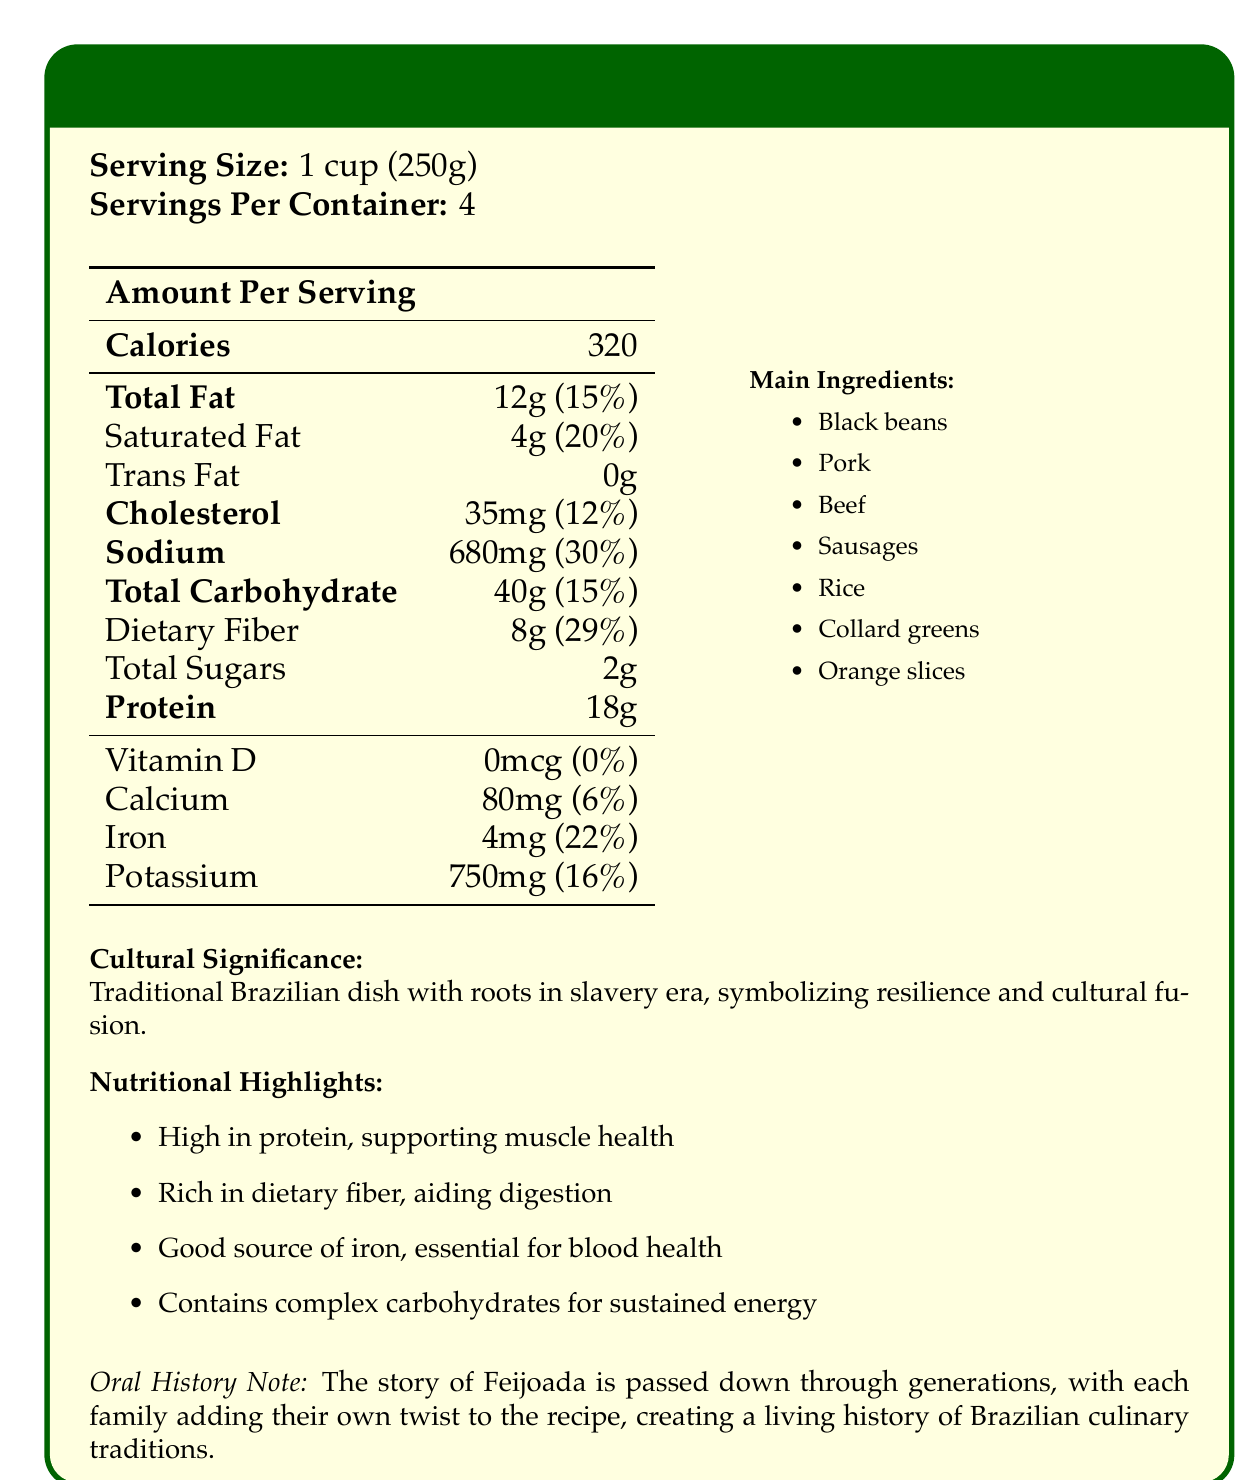what is the serving size of Feijoada? The serving size is clearly mentioned as "1 cup (250g)" in the minipage section of the document.
Answer: 1 cup (250g) how many calories are there per serving of Feijoada? The document states that there are 320 calories per serving under the "Calories" row in the table.
Answer: 320 what is the daily value percentage of dietary fiber in Feijoada? The daily value percentage for dietary fiber is listed as 29% next to the dietary fiber amount of 8g in the nutritional table.
Answer: 29% what are the main ingredients of Feijoada? The main ingredients are listed on the right side of the document under "Main Ingredients".
Answer: Black beans, Pork, Beef, Sausages, Rice, Collard Greens, Orange Slices what is the historical context of Feijoada? The historical context is mentioned below the cultural significance section in the document.
Answer: Feijoada originated in the 16th century among enslaved Africans on Brazilian plantations, who created the dish using leftover meat parts given by slave owners what is one of the nutritional highlights of Feijoada? One of the nutritional highlights listed is that Feijoada is high in protein, which supports muscle health.
Answer: High in protein, supporting muscle health what percentage of the daily value of sodium does Feijoada provide? A. 12% B. 20% C. 30% D. 50% The daily value percentage for sodium is 30%, as stated in the nutritional table.
Answer: C. 30% how much iron does one serving of Feijoada contain? A. 2mg B. 4mg C. 6mg D. 8mg The nutritional table lists iron content as 4mg.
Answer: B. 4mg is Feijoada considered a good source of vitamin D? According to the document, Feijoada contains 0mcg of vitamin D, which is 0% of the daily value.
Answer: No summarize the document in a few sentences. The document provides an overview of Feijoada's nutritional facts along with its cultural and historical context, showcasing its health benefits and importance in Brazilian culture.
Answer: The document provides nutritional information about Feijoada, highlighting its serving size, caloric content, and nutritional value per serving. It outlines main ingredients and nutritional highlights, pointing out its high protein, dietary fiber, and iron content. It also describes the historical and cultural significance of Feijoada, noting its roots in the slavery era and its role as a symbol of resilience and cultural fusion. which ingredient is usually served alongside Feijoada for added flavor? Orange slices are listed as one of the main ingredients, which are typically served alongside Feijoada for added flavor.
Answer: Orange slices cannot be determined from the document. The document provides the main ingredients but does not give specific measurements or cooking instructions, so the exact recipe cannot be determined from the document.
Answer: What is the exact recipe for Feijoada? 